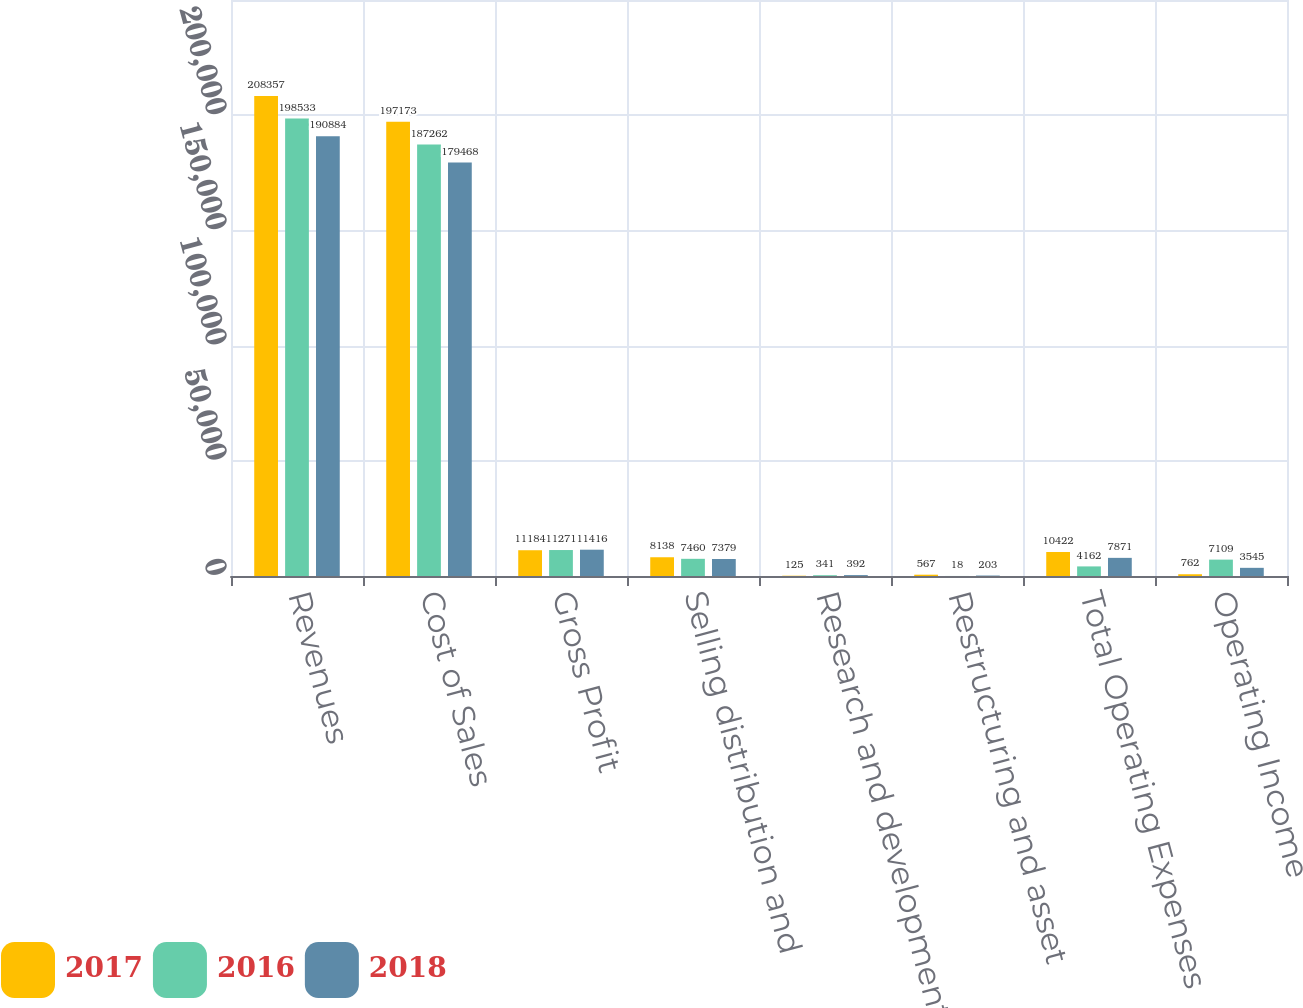Convert chart. <chart><loc_0><loc_0><loc_500><loc_500><stacked_bar_chart><ecel><fcel>Revenues<fcel>Cost of Sales<fcel>Gross Profit<fcel>Selling distribution and<fcel>Research and development<fcel>Restructuring and asset<fcel>Total Operating Expenses<fcel>Operating Income<nl><fcel>2017<fcel>208357<fcel>197173<fcel>11184<fcel>8138<fcel>125<fcel>567<fcel>10422<fcel>762<nl><fcel>2016<fcel>198533<fcel>187262<fcel>11271<fcel>7460<fcel>341<fcel>18<fcel>4162<fcel>7109<nl><fcel>2018<fcel>190884<fcel>179468<fcel>11416<fcel>7379<fcel>392<fcel>203<fcel>7871<fcel>3545<nl></chart> 